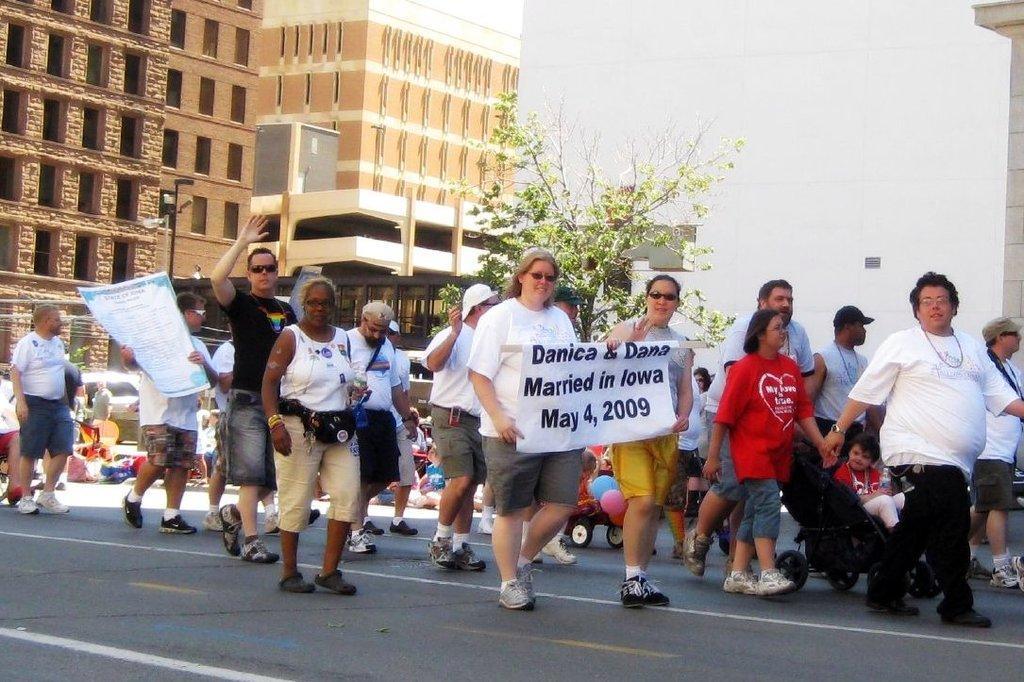Can you describe this image briefly? In the image in the center we can see group of people were walking on the road and few people were holding banners. In the background we can see buildings,wall,pillar,poles,vehicles,trees,road,baby wheel,balloons,few people and few other objects. 